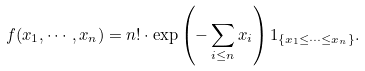<formula> <loc_0><loc_0><loc_500><loc_500>f ( x _ { 1 } , \cdots , x _ { n } ) = n ! \cdot \exp \left ( - \sum _ { i \leq n } x _ { i } \right ) 1 _ { \{ x _ { 1 } \leq \cdots \leq x _ { n } \} } .</formula> 